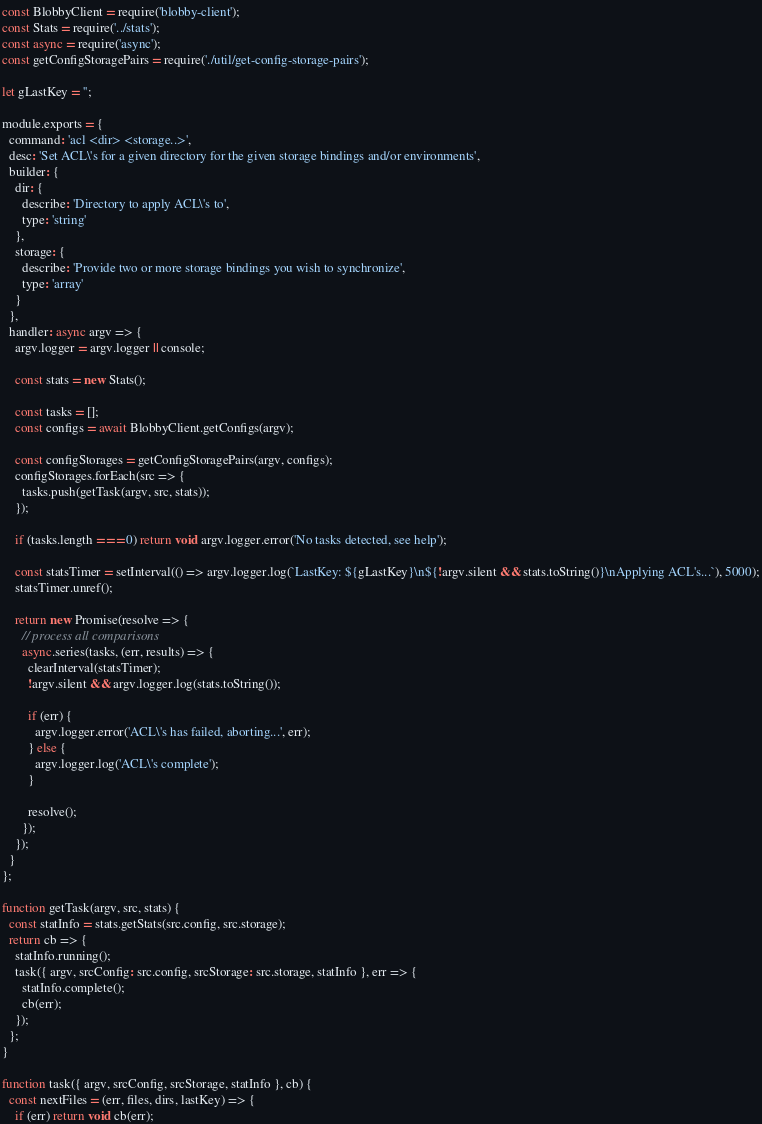Convert code to text. <code><loc_0><loc_0><loc_500><loc_500><_JavaScript_>const BlobbyClient = require('blobby-client');
const Stats = require('../stats');
const async = require('async');
const getConfigStoragePairs = require('./util/get-config-storage-pairs');

let gLastKey = '';

module.exports = {
  command: 'acl <dir> <storage..>',
  desc: 'Set ACL\'s for a given directory for the given storage bindings and/or environments',
  builder: {
    dir: {
      describe: 'Directory to apply ACL\'s to',
      type: 'string'
    },
    storage: {
      describe: 'Provide two or more storage bindings you wish to synchronize',
      type: 'array'
    }
  },
  handler: async argv => {
    argv.logger = argv.logger || console;

    const stats = new Stats();

    const tasks = [];
    const configs = await BlobbyClient.getConfigs(argv);

    const configStorages = getConfigStoragePairs(argv, configs);
    configStorages.forEach(src => {
      tasks.push(getTask(argv, src, stats));
    });

    if (tasks.length === 0) return void argv.logger.error('No tasks detected, see help');

    const statsTimer = setInterval(() => argv.logger.log(`LastKey: ${gLastKey}\n${!argv.silent && stats.toString()}\nApplying ACL's...`), 5000);
    statsTimer.unref();

    return new Promise(resolve => {
      // process all comparisons
      async.series(tasks, (err, results) => {
        clearInterval(statsTimer);
        !argv.silent && argv.logger.log(stats.toString());

        if (err) {
          argv.logger.error('ACL\'s has failed, aborting...', err);
        } else {
          argv.logger.log('ACL\'s complete');
        }

        resolve();
      });
    });
  }
};

function getTask(argv, src, stats) {
  const statInfo = stats.getStats(src.config, src.storage);
  return cb => {
    statInfo.running();
    task({ argv, srcConfig: src.config, srcStorage: src.storage, statInfo }, err => {
      statInfo.complete();
      cb(err);
    });
  };
}

function task({ argv, srcConfig, srcStorage, statInfo }, cb) {
  const nextFiles = (err, files, dirs, lastKey) => {
    if (err) return void cb(err);</code> 